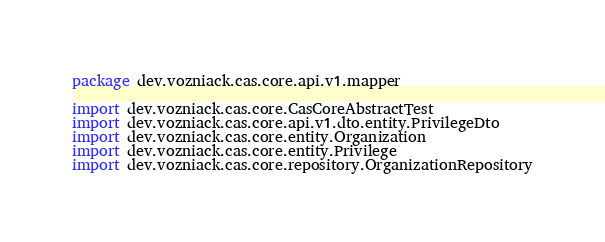Convert code to text. <code><loc_0><loc_0><loc_500><loc_500><_Kotlin_>package dev.vozniack.cas.core.api.v1.mapper

import dev.vozniack.cas.core.CasCoreAbstractTest
import dev.vozniack.cas.core.api.v1.dto.entity.PrivilegeDto
import dev.vozniack.cas.core.entity.Organization
import dev.vozniack.cas.core.entity.Privilege
import dev.vozniack.cas.core.repository.OrganizationRepository</code> 